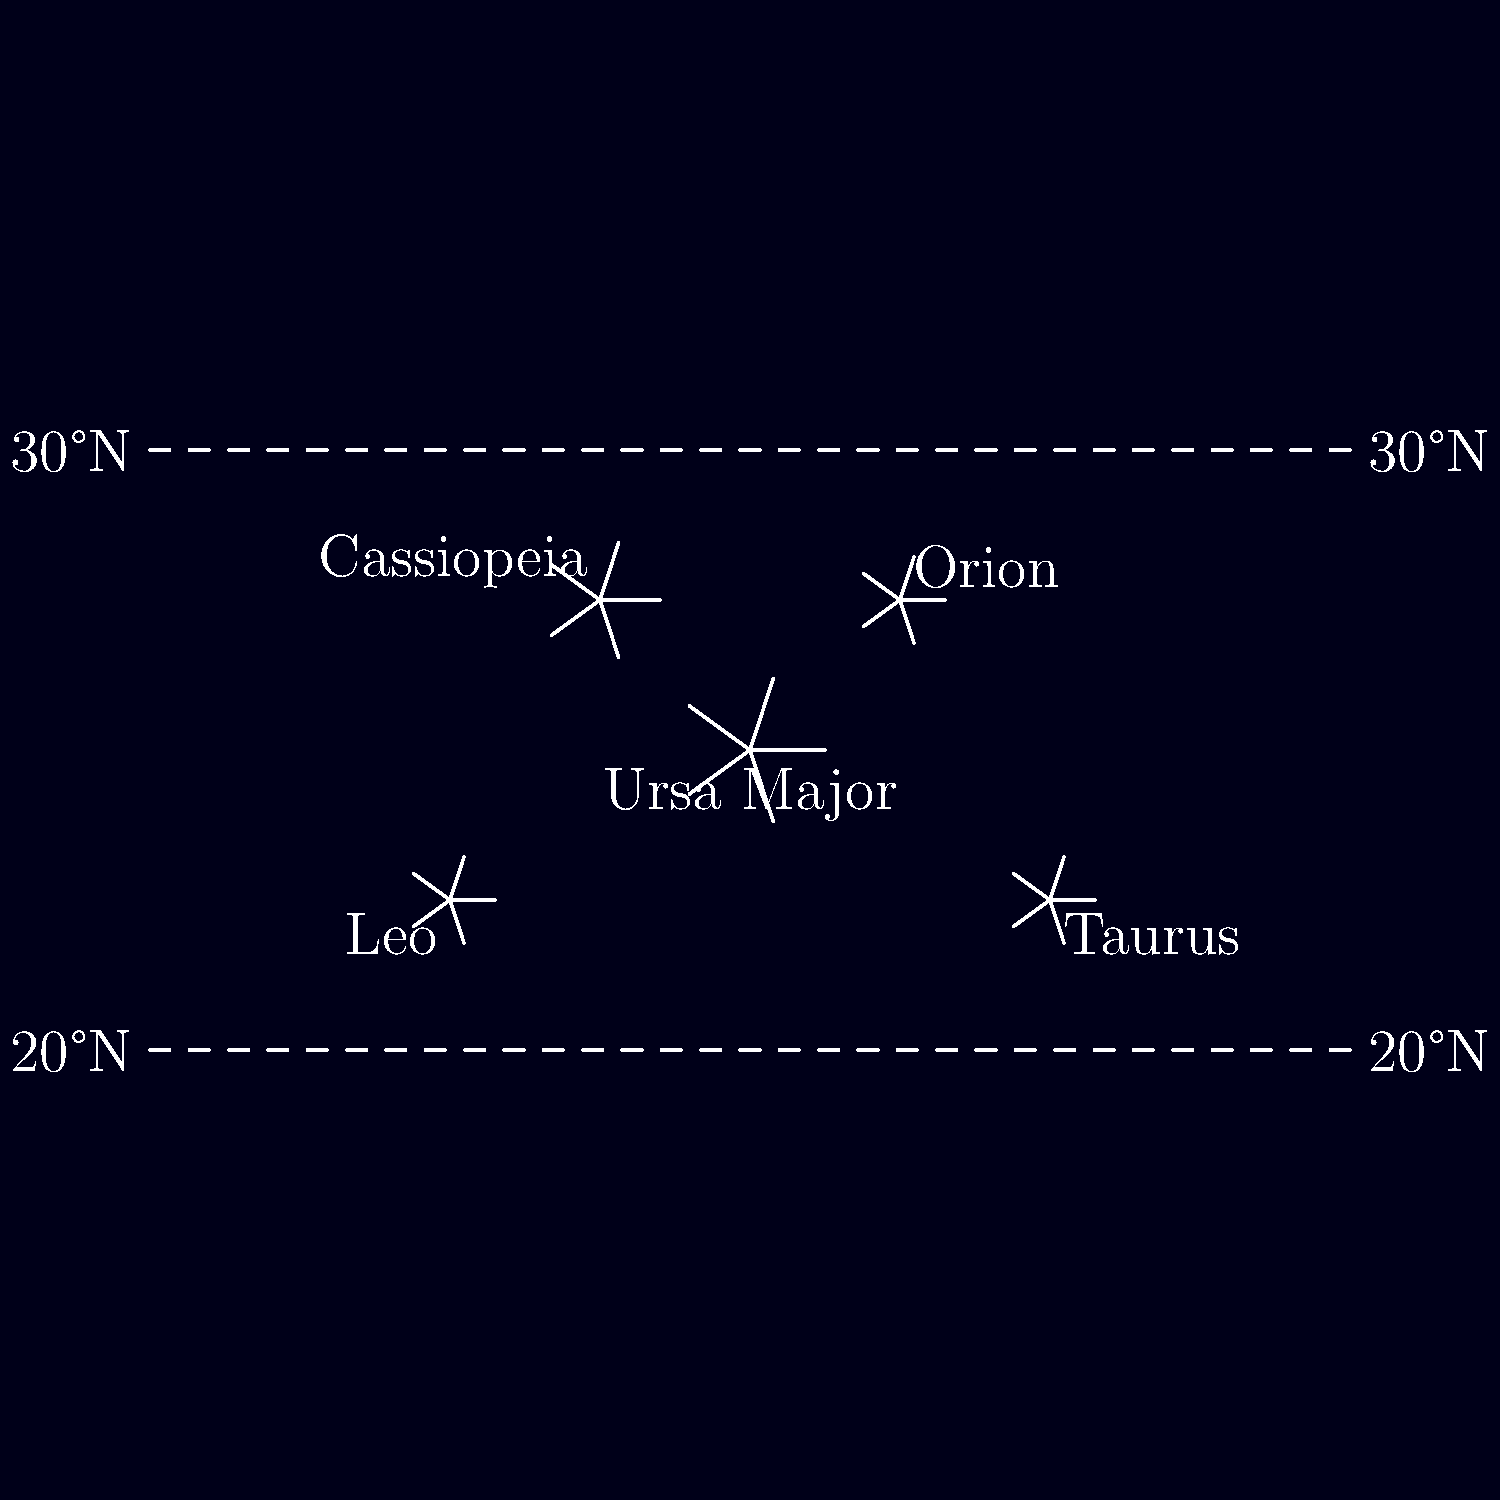Based on the star chart showing constellations visible from both India and Pakistan, which constellation is prominently visible near the center and is known for its distinctive "Big Dipper" asterism? To answer this question, let's analyze the star chart step by step:

1. The chart shows several constellations visible from latitudes between 20°N and 30°N, which encompass most of India and Pakistan.

2. Five constellations are labeled on the chart: Ursa Major, Orion, Cassiopeia, Taurus, and Leo.

3. Among these, Ursa Major is positioned at the center of the chart.

4. Ursa Major, also known as the Great Bear, is famous for containing the easily recognizable "Big Dipper" asterism.

5. The Big Dipper is a group of seven bright stars within Ursa Major that form a shape resembling a large ladle or dipper.

6. This asterism is visible year-round from the latitudes of India and Pakistan, making it a common sight for observers in both countries.

7. The prominence and central position of Ursa Major in the chart, combined with its well-known "Big Dipper" feature, make it the correct answer to the question.
Answer: Ursa Major 